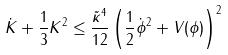<formula> <loc_0><loc_0><loc_500><loc_500>\dot { K } + \frac { 1 } { 3 } K ^ { 2 } \leq \frac { \tilde { \kappa } ^ { 4 } } { 1 2 } \left ( \frac { 1 } { 2 } \dot { \phi } ^ { 2 } + V ( \phi ) \right ) ^ { 2 }</formula> 